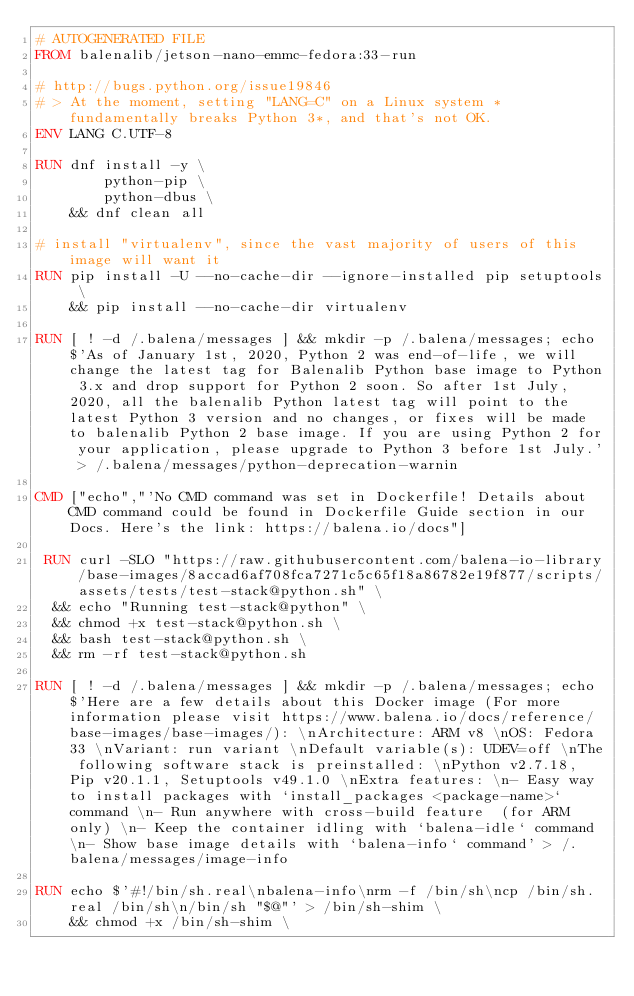Convert code to text. <code><loc_0><loc_0><loc_500><loc_500><_Dockerfile_># AUTOGENERATED FILE
FROM balenalib/jetson-nano-emmc-fedora:33-run

# http://bugs.python.org/issue19846
# > At the moment, setting "LANG=C" on a Linux system *fundamentally breaks Python 3*, and that's not OK.
ENV LANG C.UTF-8

RUN dnf install -y \
		python-pip \
		python-dbus \
	&& dnf clean all

# install "virtualenv", since the vast majority of users of this image will want it
RUN pip install -U --no-cache-dir --ignore-installed pip setuptools \
	&& pip install --no-cache-dir virtualenv

RUN [ ! -d /.balena/messages ] && mkdir -p /.balena/messages; echo $'As of January 1st, 2020, Python 2 was end-of-life, we will change the latest tag for Balenalib Python base image to Python 3.x and drop support for Python 2 soon. So after 1st July, 2020, all the balenalib Python latest tag will point to the latest Python 3 version and no changes, or fixes will be made to balenalib Python 2 base image. If you are using Python 2 for your application, please upgrade to Python 3 before 1st July.' > /.balena/messages/python-deprecation-warnin

CMD ["echo","'No CMD command was set in Dockerfile! Details about CMD command could be found in Dockerfile Guide section in our Docs. Here's the link: https://balena.io/docs"]

 RUN curl -SLO "https://raw.githubusercontent.com/balena-io-library/base-images/8accad6af708fca7271c5c65f18a86782e19f877/scripts/assets/tests/test-stack@python.sh" \
  && echo "Running test-stack@python" \
  && chmod +x test-stack@python.sh \
  && bash test-stack@python.sh \
  && rm -rf test-stack@python.sh 

RUN [ ! -d /.balena/messages ] && mkdir -p /.balena/messages; echo $'Here are a few details about this Docker image (For more information please visit https://www.balena.io/docs/reference/base-images/base-images/): \nArchitecture: ARM v8 \nOS: Fedora 33 \nVariant: run variant \nDefault variable(s): UDEV=off \nThe following software stack is preinstalled: \nPython v2.7.18, Pip v20.1.1, Setuptools v49.1.0 \nExtra features: \n- Easy way to install packages with `install_packages <package-name>` command \n- Run anywhere with cross-build feature  (for ARM only) \n- Keep the container idling with `balena-idle` command \n- Show base image details with `balena-info` command' > /.balena/messages/image-info

RUN echo $'#!/bin/sh.real\nbalena-info\nrm -f /bin/sh\ncp /bin/sh.real /bin/sh\n/bin/sh "$@"' > /bin/sh-shim \
	&& chmod +x /bin/sh-shim \</code> 